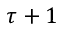<formula> <loc_0><loc_0><loc_500><loc_500>\tau + 1</formula> 